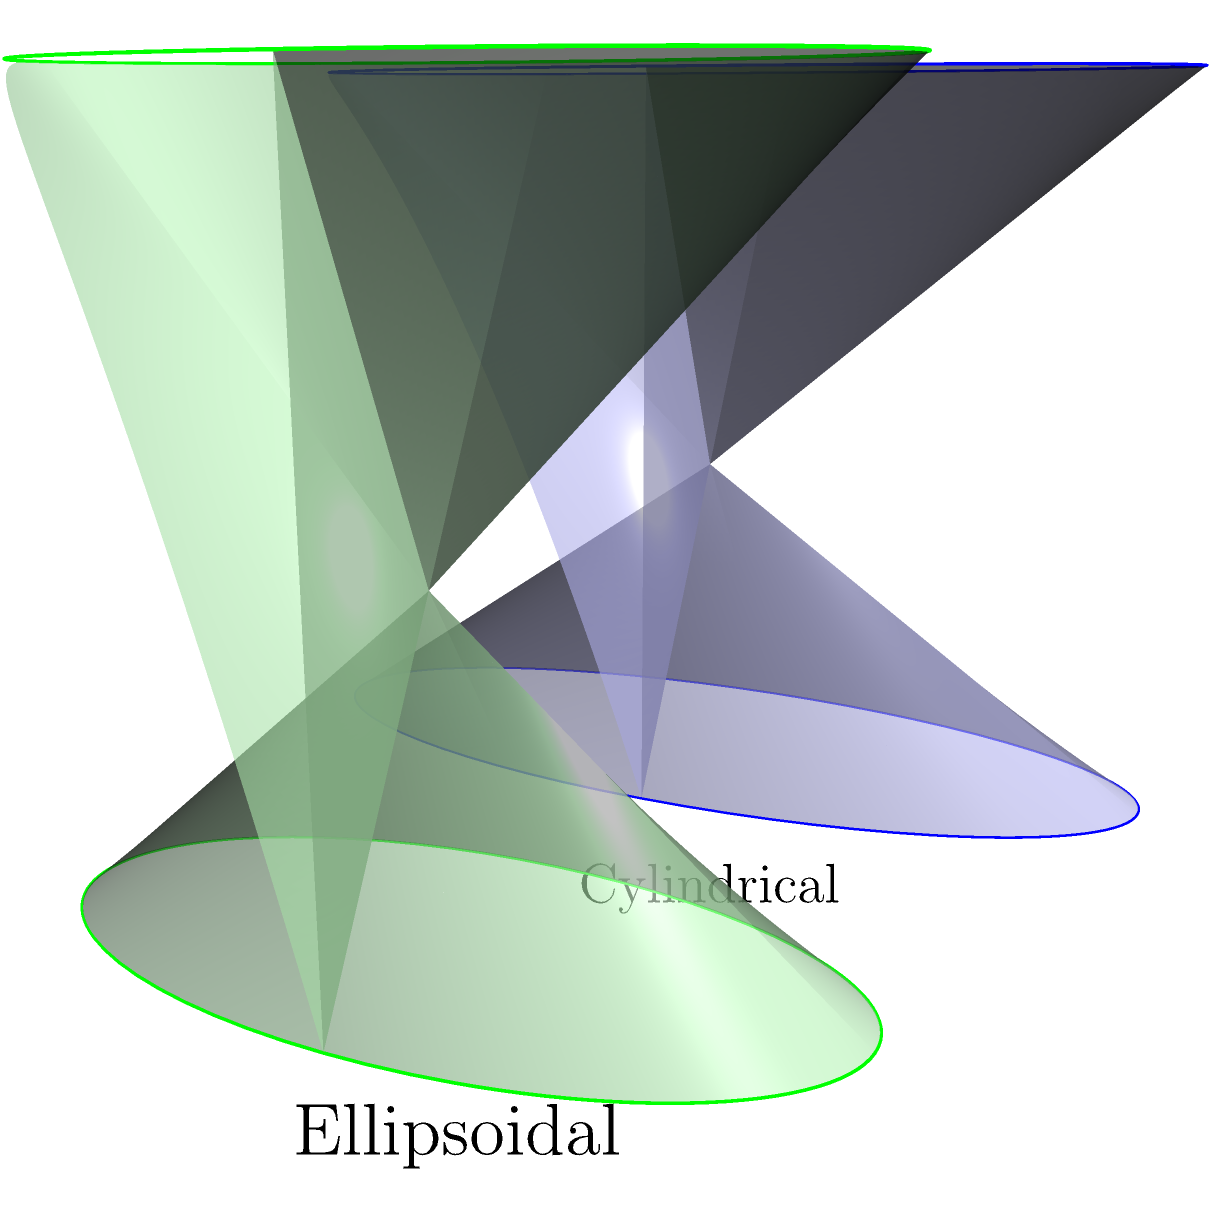As a travel photographer documenting the winemaking process, you come across two uniquely shaped wine barrels: a cylindrical barrel and an ellipsoidal barrel. Both barrels have the same height of 2 meters. The cylindrical barrel has a radius of 0.5 meters, while the ellipsoidal barrel has a circular top and bottom with a radius of 0.5 meters, but its width is 20% less than its depth.

Calculate the difference in volume between these two barrels. Express your answer in cubic meters, rounded to two decimal places. To solve this problem, we need to calculate the volumes of both barrels and then find their difference.

1. Cylindrical barrel volume:
   $V_{cyl} = \pi r^2 h$
   where $r = 0.5$ m and $h = 2$ m
   $V_{cyl} = \pi (0.5)^2 (2) = 0.5\pi$ m³

2. Ellipsoidal barrel volume:
   The ellipsoidal barrel is actually a cylindrical barrel with an elliptical base.
   Its volume can be calculated as:
   $V_{ell} = \pi a b h$
   where $a = 0.5$ m (radius in one direction)
   $b = 0.8a = 0.8(0.5) = 0.4$ m (radius in the other direction, 20% less)
   $h = 2$ m

   $V_{ell} = \pi (0.5)(0.4)(2) = 0.4\pi$ m³

3. Difference in volume:
   $\Delta V = V_{cyl} - V_{ell} = 0.5\pi - 0.4\pi = 0.1\pi$ m³

4. Converting to a decimal and rounding:
   $0.1\pi \approx 0.31$ m³ (rounded to two decimal places)
Answer: 0.31 m³ 